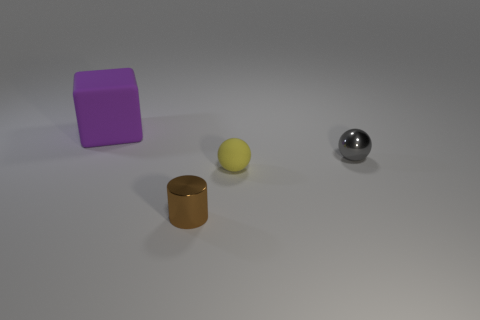Add 3 big purple cylinders. How many objects exist? 7 Subtract all blocks. How many objects are left? 3 Subtract all small brown metal cylinders. Subtract all small metal things. How many objects are left? 1 Add 4 large rubber blocks. How many large rubber blocks are left? 5 Add 1 brown cylinders. How many brown cylinders exist? 2 Subtract 0 green cubes. How many objects are left? 4 